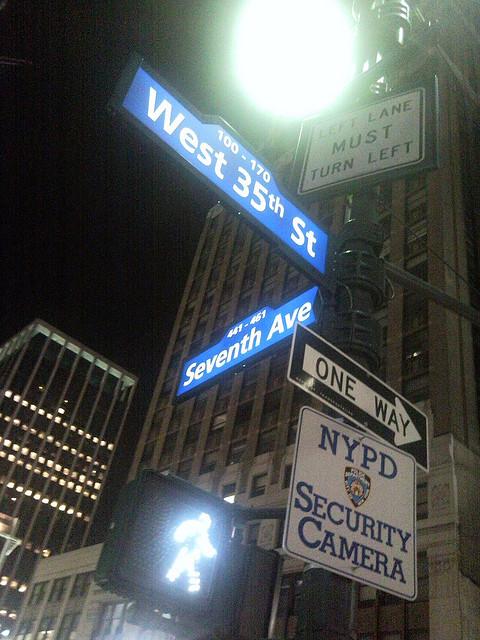What is making the street signs appear so bright?
Quick response, please. Light. What does the street sign say?
Quick response, please. West 35th st. Who has a security camera?
Quick response, please. Nypd. 